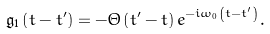<formula> <loc_0><loc_0><loc_500><loc_500>\mathfrak { g } _ { 1 } \left ( t - t ^ { \prime } \right ) = - \Theta \left ( t ^ { \prime } - t \right ) e ^ { - i \omega _ { 0 } \left ( t - t ^ { \prime } \right ) } .</formula> 